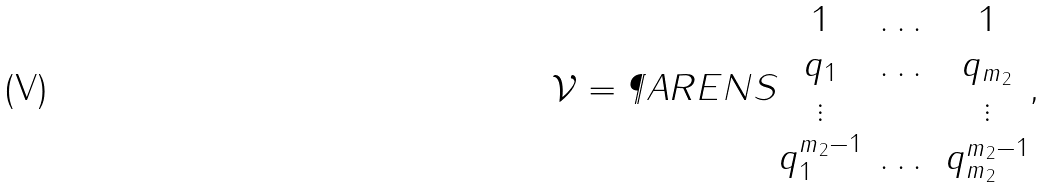<formula> <loc_0><loc_0><loc_500><loc_500>\mathcal { V } = \P A R E N S { \begin{matrix} 1 & \dots & 1 \\ q _ { 1 } & \dots & q _ { m _ { 2 } } \\ \vdots & & \vdots \\ q _ { 1 } ^ { m _ { 2 } - 1 } & \dots & q _ { m _ { 2 } } ^ { m _ { 2 } - 1 } \end{matrix} } ,</formula> 